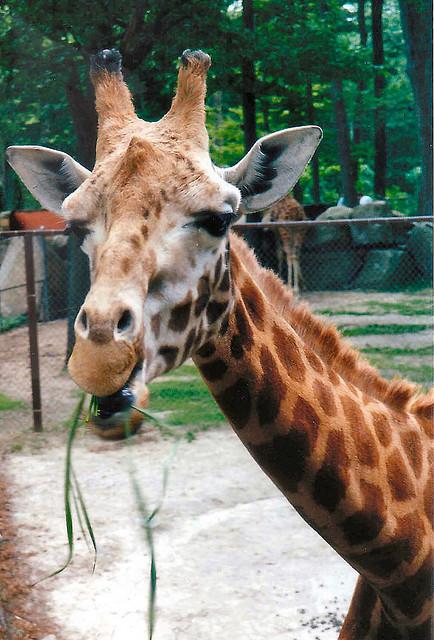Is this giraffe alone?
Give a very brief answer. No. What color is its tongue?
Keep it brief. Black. What is the giraffe being fed?
Quick response, please. Grass. What type of plant is the giraffe eating?
Quick response, please. Grass. What is the giraffe eating?
Keep it brief. Grass. What is under the giraffe's chins?
Short answer required. Grass. 